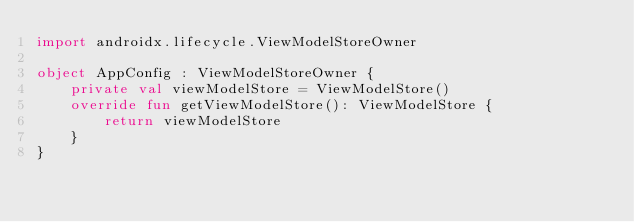Convert code to text. <code><loc_0><loc_0><loc_500><loc_500><_Kotlin_>import androidx.lifecycle.ViewModelStoreOwner

object AppConfig : ViewModelStoreOwner {
    private val viewModelStore = ViewModelStore()
    override fun getViewModelStore(): ViewModelStore {
        return viewModelStore
    }
}</code> 